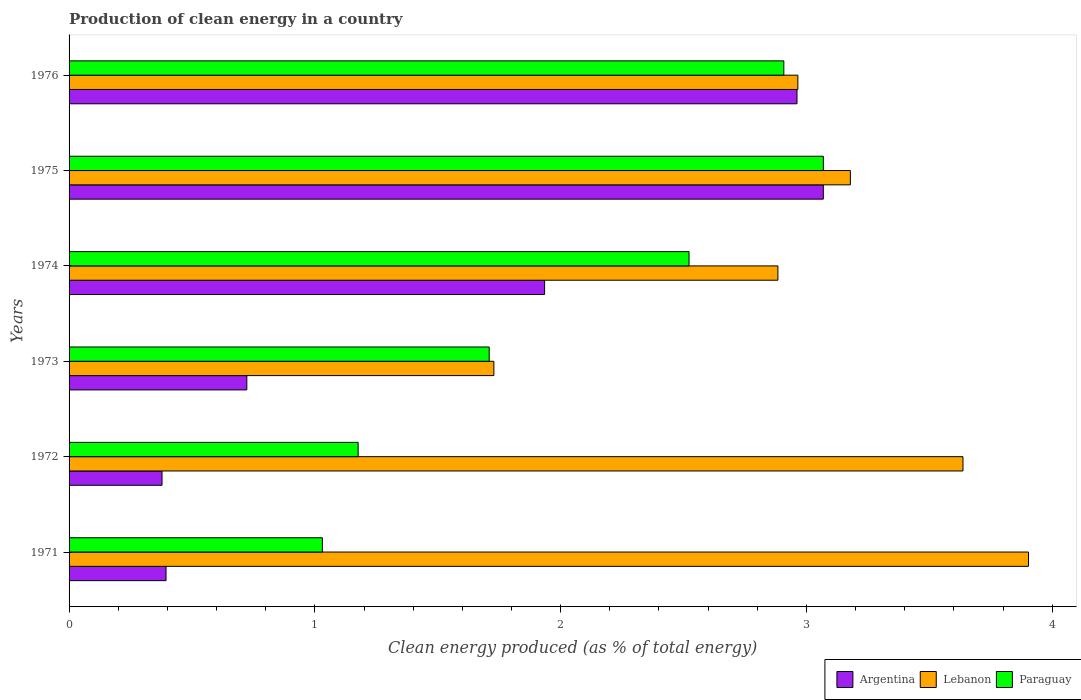How many different coloured bars are there?
Ensure brevity in your answer.  3. How many bars are there on the 6th tick from the top?
Provide a short and direct response. 3. How many bars are there on the 3rd tick from the bottom?
Provide a succinct answer. 3. What is the label of the 3rd group of bars from the top?
Keep it short and to the point. 1974. What is the percentage of clean energy produced in Argentina in 1976?
Ensure brevity in your answer.  2.96. Across all years, what is the maximum percentage of clean energy produced in Lebanon?
Make the answer very short. 3.9. Across all years, what is the minimum percentage of clean energy produced in Paraguay?
Keep it short and to the point. 1.03. In which year was the percentage of clean energy produced in Argentina maximum?
Offer a terse response. 1975. What is the total percentage of clean energy produced in Lebanon in the graph?
Your answer should be very brief. 18.3. What is the difference between the percentage of clean energy produced in Argentina in 1971 and that in 1975?
Make the answer very short. -2.67. What is the difference between the percentage of clean energy produced in Argentina in 1976 and the percentage of clean energy produced in Paraguay in 1972?
Give a very brief answer. 1.79. What is the average percentage of clean energy produced in Lebanon per year?
Your answer should be compact. 3.05. In the year 1974, what is the difference between the percentage of clean energy produced in Argentina and percentage of clean energy produced in Lebanon?
Keep it short and to the point. -0.95. In how many years, is the percentage of clean energy produced in Argentina greater than 2.8 %?
Your answer should be very brief. 2. What is the ratio of the percentage of clean energy produced in Lebanon in 1974 to that in 1975?
Your response must be concise. 0.91. Is the difference between the percentage of clean energy produced in Argentina in 1971 and 1974 greater than the difference between the percentage of clean energy produced in Lebanon in 1971 and 1974?
Offer a very short reply. No. What is the difference between the highest and the second highest percentage of clean energy produced in Paraguay?
Make the answer very short. 0.16. What is the difference between the highest and the lowest percentage of clean energy produced in Argentina?
Your answer should be compact. 2.69. In how many years, is the percentage of clean energy produced in Argentina greater than the average percentage of clean energy produced in Argentina taken over all years?
Your answer should be compact. 3. Is the sum of the percentage of clean energy produced in Argentina in 1972 and 1974 greater than the maximum percentage of clean energy produced in Paraguay across all years?
Make the answer very short. No. What does the 3rd bar from the bottom in 1976 represents?
Give a very brief answer. Paraguay. Are all the bars in the graph horizontal?
Your answer should be compact. Yes. How many years are there in the graph?
Keep it short and to the point. 6. Are the values on the major ticks of X-axis written in scientific E-notation?
Make the answer very short. No. Does the graph contain any zero values?
Offer a terse response. No. Where does the legend appear in the graph?
Offer a very short reply. Bottom right. How many legend labels are there?
Make the answer very short. 3. What is the title of the graph?
Give a very brief answer. Production of clean energy in a country. Does "OECD members" appear as one of the legend labels in the graph?
Ensure brevity in your answer.  No. What is the label or title of the X-axis?
Give a very brief answer. Clean energy produced (as % of total energy). What is the label or title of the Y-axis?
Your answer should be very brief. Years. What is the Clean energy produced (as % of total energy) in Argentina in 1971?
Your response must be concise. 0.39. What is the Clean energy produced (as % of total energy) of Lebanon in 1971?
Provide a succinct answer. 3.9. What is the Clean energy produced (as % of total energy) of Paraguay in 1971?
Your answer should be compact. 1.03. What is the Clean energy produced (as % of total energy) in Argentina in 1972?
Your response must be concise. 0.38. What is the Clean energy produced (as % of total energy) of Lebanon in 1972?
Provide a short and direct response. 3.64. What is the Clean energy produced (as % of total energy) in Paraguay in 1972?
Make the answer very short. 1.18. What is the Clean energy produced (as % of total energy) of Argentina in 1973?
Ensure brevity in your answer.  0.72. What is the Clean energy produced (as % of total energy) in Lebanon in 1973?
Make the answer very short. 1.73. What is the Clean energy produced (as % of total energy) of Paraguay in 1973?
Your answer should be very brief. 1.71. What is the Clean energy produced (as % of total energy) in Argentina in 1974?
Offer a terse response. 1.93. What is the Clean energy produced (as % of total energy) in Lebanon in 1974?
Offer a terse response. 2.88. What is the Clean energy produced (as % of total energy) of Paraguay in 1974?
Your answer should be compact. 2.52. What is the Clean energy produced (as % of total energy) of Argentina in 1975?
Provide a short and direct response. 3.07. What is the Clean energy produced (as % of total energy) of Lebanon in 1975?
Provide a succinct answer. 3.18. What is the Clean energy produced (as % of total energy) of Paraguay in 1975?
Make the answer very short. 3.07. What is the Clean energy produced (as % of total energy) in Argentina in 1976?
Your answer should be compact. 2.96. What is the Clean energy produced (as % of total energy) in Lebanon in 1976?
Your answer should be compact. 2.97. What is the Clean energy produced (as % of total energy) in Paraguay in 1976?
Provide a short and direct response. 2.91. Across all years, what is the maximum Clean energy produced (as % of total energy) in Argentina?
Offer a very short reply. 3.07. Across all years, what is the maximum Clean energy produced (as % of total energy) of Lebanon?
Keep it short and to the point. 3.9. Across all years, what is the maximum Clean energy produced (as % of total energy) of Paraguay?
Give a very brief answer. 3.07. Across all years, what is the minimum Clean energy produced (as % of total energy) in Argentina?
Your answer should be very brief. 0.38. Across all years, what is the minimum Clean energy produced (as % of total energy) in Lebanon?
Your answer should be compact. 1.73. Across all years, what is the minimum Clean energy produced (as % of total energy) of Paraguay?
Provide a succinct answer. 1.03. What is the total Clean energy produced (as % of total energy) in Argentina in the graph?
Ensure brevity in your answer.  9.46. What is the total Clean energy produced (as % of total energy) of Lebanon in the graph?
Your response must be concise. 18.3. What is the total Clean energy produced (as % of total energy) of Paraguay in the graph?
Provide a short and direct response. 12.42. What is the difference between the Clean energy produced (as % of total energy) in Argentina in 1971 and that in 1972?
Provide a succinct answer. 0.02. What is the difference between the Clean energy produced (as % of total energy) in Lebanon in 1971 and that in 1972?
Your answer should be very brief. 0.27. What is the difference between the Clean energy produced (as % of total energy) of Paraguay in 1971 and that in 1972?
Give a very brief answer. -0.15. What is the difference between the Clean energy produced (as % of total energy) of Argentina in 1971 and that in 1973?
Your response must be concise. -0.33. What is the difference between the Clean energy produced (as % of total energy) in Lebanon in 1971 and that in 1973?
Your response must be concise. 2.18. What is the difference between the Clean energy produced (as % of total energy) of Paraguay in 1971 and that in 1973?
Offer a very short reply. -0.68. What is the difference between the Clean energy produced (as % of total energy) in Argentina in 1971 and that in 1974?
Offer a terse response. -1.54. What is the difference between the Clean energy produced (as % of total energy) in Lebanon in 1971 and that in 1974?
Provide a short and direct response. 1.02. What is the difference between the Clean energy produced (as % of total energy) of Paraguay in 1971 and that in 1974?
Give a very brief answer. -1.49. What is the difference between the Clean energy produced (as % of total energy) of Argentina in 1971 and that in 1975?
Make the answer very short. -2.67. What is the difference between the Clean energy produced (as % of total energy) of Lebanon in 1971 and that in 1975?
Give a very brief answer. 0.72. What is the difference between the Clean energy produced (as % of total energy) of Paraguay in 1971 and that in 1975?
Keep it short and to the point. -2.04. What is the difference between the Clean energy produced (as % of total energy) of Argentina in 1971 and that in 1976?
Provide a short and direct response. -2.57. What is the difference between the Clean energy produced (as % of total energy) in Lebanon in 1971 and that in 1976?
Offer a very short reply. 0.94. What is the difference between the Clean energy produced (as % of total energy) in Paraguay in 1971 and that in 1976?
Make the answer very short. -1.88. What is the difference between the Clean energy produced (as % of total energy) of Argentina in 1972 and that in 1973?
Provide a succinct answer. -0.34. What is the difference between the Clean energy produced (as % of total energy) in Lebanon in 1972 and that in 1973?
Your answer should be compact. 1.91. What is the difference between the Clean energy produced (as % of total energy) of Paraguay in 1972 and that in 1973?
Provide a short and direct response. -0.53. What is the difference between the Clean energy produced (as % of total energy) of Argentina in 1972 and that in 1974?
Provide a short and direct response. -1.56. What is the difference between the Clean energy produced (as % of total energy) of Lebanon in 1972 and that in 1974?
Your answer should be compact. 0.75. What is the difference between the Clean energy produced (as % of total energy) in Paraguay in 1972 and that in 1974?
Keep it short and to the point. -1.35. What is the difference between the Clean energy produced (as % of total energy) of Argentina in 1972 and that in 1975?
Make the answer very short. -2.69. What is the difference between the Clean energy produced (as % of total energy) in Lebanon in 1972 and that in 1975?
Provide a succinct answer. 0.46. What is the difference between the Clean energy produced (as % of total energy) in Paraguay in 1972 and that in 1975?
Your answer should be compact. -1.89. What is the difference between the Clean energy produced (as % of total energy) of Argentina in 1972 and that in 1976?
Offer a terse response. -2.58. What is the difference between the Clean energy produced (as % of total energy) of Lebanon in 1972 and that in 1976?
Provide a succinct answer. 0.67. What is the difference between the Clean energy produced (as % of total energy) of Paraguay in 1972 and that in 1976?
Ensure brevity in your answer.  -1.73. What is the difference between the Clean energy produced (as % of total energy) of Argentina in 1973 and that in 1974?
Provide a short and direct response. -1.21. What is the difference between the Clean energy produced (as % of total energy) in Lebanon in 1973 and that in 1974?
Provide a short and direct response. -1.16. What is the difference between the Clean energy produced (as % of total energy) in Paraguay in 1973 and that in 1974?
Make the answer very short. -0.81. What is the difference between the Clean energy produced (as % of total energy) of Argentina in 1973 and that in 1975?
Your answer should be compact. -2.35. What is the difference between the Clean energy produced (as % of total energy) of Lebanon in 1973 and that in 1975?
Your response must be concise. -1.45. What is the difference between the Clean energy produced (as % of total energy) in Paraguay in 1973 and that in 1975?
Give a very brief answer. -1.36. What is the difference between the Clean energy produced (as % of total energy) of Argentina in 1973 and that in 1976?
Keep it short and to the point. -2.24. What is the difference between the Clean energy produced (as % of total energy) in Lebanon in 1973 and that in 1976?
Keep it short and to the point. -1.24. What is the difference between the Clean energy produced (as % of total energy) in Paraguay in 1973 and that in 1976?
Your answer should be compact. -1.2. What is the difference between the Clean energy produced (as % of total energy) of Argentina in 1974 and that in 1975?
Give a very brief answer. -1.13. What is the difference between the Clean energy produced (as % of total energy) in Lebanon in 1974 and that in 1975?
Offer a terse response. -0.29. What is the difference between the Clean energy produced (as % of total energy) in Paraguay in 1974 and that in 1975?
Provide a short and direct response. -0.55. What is the difference between the Clean energy produced (as % of total energy) of Argentina in 1974 and that in 1976?
Ensure brevity in your answer.  -1.03. What is the difference between the Clean energy produced (as % of total energy) of Lebanon in 1974 and that in 1976?
Provide a short and direct response. -0.08. What is the difference between the Clean energy produced (as % of total energy) of Paraguay in 1974 and that in 1976?
Your response must be concise. -0.39. What is the difference between the Clean energy produced (as % of total energy) of Argentina in 1975 and that in 1976?
Provide a short and direct response. 0.11. What is the difference between the Clean energy produced (as % of total energy) in Lebanon in 1975 and that in 1976?
Provide a short and direct response. 0.21. What is the difference between the Clean energy produced (as % of total energy) in Paraguay in 1975 and that in 1976?
Offer a terse response. 0.16. What is the difference between the Clean energy produced (as % of total energy) in Argentina in 1971 and the Clean energy produced (as % of total energy) in Lebanon in 1972?
Your response must be concise. -3.24. What is the difference between the Clean energy produced (as % of total energy) of Argentina in 1971 and the Clean energy produced (as % of total energy) of Paraguay in 1972?
Your answer should be compact. -0.78. What is the difference between the Clean energy produced (as % of total energy) of Lebanon in 1971 and the Clean energy produced (as % of total energy) of Paraguay in 1972?
Give a very brief answer. 2.73. What is the difference between the Clean energy produced (as % of total energy) of Argentina in 1971 and the Clean energy produced (as % of total energy) of Lebanon in 1973?
Offer a very short reply. -1.33. What is the difference between the Clean energy produced (as % of total energy) of Argentina in 1971 and the Clean energy produced (as % of total energy) of Paraguay in 1973?
Make the answer very short. -1.31. What is the difference between the Clean energy produced (as % of total energy) of Lebanon in 1971 and the Clean energy produced (as % of total energy) of Paraguay in 1973?
Your answer should be compact. 2.19. What is the difference between the Clean energy produced (as % of total energy) of Argentina in 1971 and the Clean energy produced (as % of total energy) of Lebanon in 1974?
Provide a short and direct response. -2.49. What is the difference between the Clean energy produced (as % of total energy) in Argentina in 1971 and the Clean energy produced (as % of total energy) in Paraguay in 1974?
Offer a terse response. -2.13. What is the difference between the Clean energy produced (as % of total energy) of Lebanon in 1971 and the Clean energy produced (as % of total energy) of Paraguay in 1974?
Offer a terse response. 1.38. What is the difference between the Clean energy produced (as % of total energy) in Argentina in 1971 and the Clean energy produced (as % of total energy) in Lebanon in 1975?
Provide a short and direct response. -2.78. What is the difference between the Clean energy produced (as % of total energy) of Argentina in 1971 and the Clean energy produced (as % of total energy) of Paraguay in 1975?
Provide a short and direct response. -2.67. What is the difference between the Clean energy produced (as % of total energy) in Lebanon in 1971 and the Clean energy produced (as % of total energy) in Paraguay in 1975?
Make the answer very short. 0.83. What is the difference between the Clean energy produced (as % of total energy) of Argentina in 1971 and the Clean energy produced (as % of total energy) of Lebanon in 1976?
Your answer should be compact. -2.57. What is the difference between the Clean energy produced (as % of total energy) of Argentina in 1971 and the Clean energy produced (as % of total energy) of Paraguay in 1976?
Your response must be concise. -2.51. What is the difference between the Clean energy produced (as % of total energy) of Argentina in 1972 and the Clean energy produced (as % of total energy) of Lebanon in 1973?
Ensure brevity in your answer.  -1.35. What is the difference between the Clean energy produced (as % of total energy) of Argentina in 1972 and the Clean energy produced (as % of total energy) of Paraguay in 1973?
Keep it short and to the point. -1.33. What is the difference between the Clean energy produced (as % of total energy) of Lebanon in 1972 and the Clean energy produced (as % of total energy) of Paraguay in 1973?
Keep it short and to the point. 1.93. What is the difference between the Clean energy produced (as % of total energy) of Argentina in 1972 and the Clean energy produced (as % of total energy) of Lebanon in 1974?
Ensure brevity in your answer.  -2.51. What is the difference between the Clean energy produced (as % of total energy) in Argentina in 1972 and the Clean energy produced (as % of total energy) in Paraguay in 1974?
Provide a succinct answer. -2.14. What is the difference between the Clean energy produced (as % of total energy) of Lebanon in 1972 and the Clean energy produced (as % of total energy) of Paraguay in 1974?
Your response must be concise. 1.11. What is the difference between the Clean energy produced (as % of total energy) in Argentina in 1972 and the Clean energy produced (as % of total energy) in Lebanon in 1975?
Provide a short and direct response. -2.8. What is the difference between the Clean energy produced (as % of total energy) in Argentina in 1972 and the Clean energy produced (as % of total energy) in Paraguay in 1975?
Provide a short and direct response. -2.69. What is the difference between the Clean energy produced (as % of total energy) in Lebanon in 1972 and the Clean energy produced (as % of total energy) in Paraguay in 1975?
Ensure brevity in your answer.  0.57. What is the difference between the Clean energy produced (as % of total energy) in Argentina in 1972 and the Clean energy produced (as % of total energy) in Lebanon in 1976?
Provide a short and direct response. -2.59. What is the difference between the Clean energy produced (as % of total energy) of Argentina in 1972 and the Clean energy produced (as % of total energy) of Paraguay in 1976?
Ensure brevity in your answer.  -2.53. What is the difference between the Clean energy produced (as % of total energy) of Lebanon in 1972 and the Clean energy produced (as % of total energy) of Paraguay in 1976?
Keep it short and to the point. 0.73. What is the difference between the Clean energy produced (as % of total energy) of Argentina in 1973 and the Clean energy produced (as % of total energy) of Lebanon in 1974?
Keep it short and to the point. -2.16. What is the difference between the Clean energy produced (as % of total energy) of Argentina in 1973 and the Clean energy produced (as % of total energy) of Paraguay in 1974?
Your answer should be compact. -1.8. What is the difference between the Clean energy produced (as % of total energy) of Lebanon in 1973 and the Clean energy produced (as % of total energy) of Paraguay in 1974?
Keep it short and to the point. -0.79. What is the difference between the Clean energy produced (as % of total energy) in Argentina in 1973 and the Clean energy produced (as % of total energy) in Lebanon in 1975?
Your response must be concise. -2.46. What is the difference between the Clean energy produced (as % of total energy) in Argentina in 1973 and the Clean energy produced (as % of total energy) in Paraguay in 1975?
Make the answer very short. -2.35. What is the difference between the Clean energy produced (as % of total energy) in Lebanon in 1973 and the Clean energy produced (as % of total energy) in Paraguay in 1975?
Keep it short and to the point. -1.34. What is the difference between the Clean energy produced (as % of total energy) of Argentina in 1973 and the Clean energy produced (as % of total energy) of Lebanon in 1976?
Your answer should be very brief. -2.24. What is the difference between the Clean energy produced (as % of total energy) in Argentina in 1973 and the Clean energy produced (as % of total energy) in Paraguay in 1976?
Ensure brevity in your answer.  -2.19. What is the difference between the Clean energy produced (as % of total energy) in Lebanon in 1973 and the Clean energy produced (as % of total energy) in Paraguay in 1976?
Your answer should be compact. -1.18. What is the difference between the Clean energy produced (as % of total energy) of Argentina in 1974 and the Clean energy produced (as % of total energy) of Lebanon in 1975?
Your answer should be very brief. -1.24. What is the difference between the Clean energy produced (as % of total energy) of Argentina in 1974 and the Clean energy produced (as % of total energy) of Paraguay in 1975?
Provide a succinct answer. -1.13. What is the difference between the Clean energy produced (as % of total energy) in Lebanon in 1974 and the Clean energy produced (as % of total energy) in Paraguay in 1975?
Give a very brief answer. -0.18. What is the difference between the Clean energy produced (as % of total energy) in Argentina in 1974 and the Clean energy produced (as % of total energy) in Lebanon in 1976?
Give a very brief answer. -1.03. What is the difference between the Clean energy produced (as % of total energy) in Argentina in 1974 and the Clean energy produced (as % of total energy) in Paraguay in 1976?
Offer a very short reply. -0.97. What is the difference between the Clean energy produced (as % of total energy) in Lebanon in 1974 and the Clean energy produced (as % of total energy) in Paraguay in 1976?
Provide a succinct answer. -0.02. What is the difference between the Clean energy produced (as % of total energy) in Argentina in 1975 and the Clean energy produced (as % of total energy) in Lebanon in 1976?
Provide a short and direct response. 0.1. What is the difference between the Clean energy produced (as % of total energy) in Argentina in 1975 and the Clean energy produced (as % of total energy) in Paraguay in 1976?
Keep it short and to the point. 0.16. What is the difference between the Clean energy produced (as % of total energy) of Lebanon in 1975 and the Clean energy produced (as % of total energy) of Paraguay in 1976?
Keep it short and to the point. 0.27. What is the average Clean energy produced (as % of total energy) in Argentina per year?
Make the answer very short. 1.58. What is the average Clean energy produced (as % of total energy) in Lebanon per year?
Keep it short and to the point. 3.05. What is the average Clean energy produced (as % of total energy) of Paraguay per year?
Make the answer very short. 2.07. In the year 1971, what is the difference between the Clean energy produced (as % of total energy) of Argentina and Clean energy produced (as % of total energy) of Lebanon?
Offer a very short reply. -3.51. In the year 1971, what is the difference between the Clean energy produced (as % of total energy) in Argentina and Clean energy produced (as % of total energy) in Paraguay?
Offer a very short reply. -0.64. In the year 1971, what is the difference between the Clean energy produced (as % of total energy) in Lebanon and Clean energy produced (as % of total energy) in Paraguay?
Make the answer very short. 2.87. In the year 1972, what is the difference between the Clean energy produced (as % of total energy) in Argentina and Clean energy produced (as % of total energy) in Lebanon?
Offer a very short reply. -3.26. In the year 1972, what is the difference between the Clean energy produced (as % of total energy) in Argentina and Clean energy produced (as % of total energy) in Paraguay?
Ensure brevity in your answer.  -0.8. In the year 1972, what is the difference between the Clean energy produced (as % of total energy) in Lebanon and Clean energy produced (as % of total energy) in Paraguay?
Your response must be concise. 2.46. In the year 1973, what is the difference between the Clean energy produced (as % of total energy) in Argentina and Clean energy produced (as % of total energy) in Lebanon?
Your answer should be compact. -1.01. In the year 1973, what is the difference between the Clean energy produced (as % of total energy) of Argentina and Clean energy produced (as % of total energy) of Paraguay?
Provide a succinct answer. -0.99. In the year 1973, what is the difference between the Clean energy produced (as % of total energy) of Lebanon and Clean energy produced (as % of total energy) of Paraguay?
Your answer should be compact. 0.02. In the year 1974, what is the difference between the Clean energy produced (as % of total energy) of Argentina and Clean energy produced (as % of total energy) of Lebanon?
Offer a very short reply. -0.95. In the year 1974, what is the difference between the Clean energy produced (as % of total energy) in Argentina and Clean energy produced (as % of total energy) in Paraguay?
Your answer should be compact. -0.59. In the year 1974, what is the difference between the Clean energy produced (as % of total energy) of Lebanon and Clean energy produced (as % of total energy) of Paraguay?
Offer a terse response. 0.36. In the year 1975, what is the difference between the Clean energy produced (as % of total energy) of Argentina and Clean energy produced (as % of total energy) of Lebanon?
Your response must be concise. -0.11. In the year 1975, what is the difference between the Clean energy produced (as % of total energy) in Argentina and Clean energy produced (as % of total energy) in Paraguay?
Provide a short and direct response. -0. In the year 1975, what is the difference between the Clean energy produced (as % of total energy) of Lebanon and Clean energy produced (as % of total energy) of Paraguay?
Make the answer very short. 0.11. In the year 1976, what is the difference between the Clean energy produced (as % of total energy) of Argentina and Clean energy produced (as % of total energy) of Lebanon?
Your answer should be very brief. -0. In the year 1976, what is the difference between the Clean energy produced (as % of total energy) in Argentina and Clean energy produced (as % of total energy) in Paraguay?
Ensure brevity in your answer.  0.05. In the year 1976, what is the difference between the Clean energy produced (as % of total energy) in Lebanon and Clean energy produced (as % of total energy) in Paraguay?
Ensure brevity in your answer.  0.06. What is the ratio of the Clean energy produced (as % of total energy) in Argentina in 1971 to that in 1972?
Offer a very short reply. 1.04. What is the ratio of the Clean energy produced (as % of total energy) in Lebanon in 1971 to that in 1972?
Your answer should be compact. 1.07. What is the ratio of the Clean energy produced (as % of total energy) of Paraguay in 1971 to that in 1972?
Your answer should be compact. 0.88. What is the ratio of the Clean energy produced (as % of total energy) of Argentina in 1971 to that in 1973?
Offer a very short reply. 0.55. What is the ratio of the Clean energy produced (as % of total energy) of Lebanon in 1971 to that in 1973?
Provide a succinct answer. 2.26. What is the ratio of the Clean energy produced (as % of total energy) of Paraguay in 1971 to that in 1973?
Offer a very short reply. 0.6. What is the ratio of the Clean energy produced (as % of total energy) of Argentina in 1971 to that in 1974?
Your response must be concise. 0.2. What is the ratio of the Clean energy produced (as % of total energy) of Lebanon in 1971 to that in 1974?
Keep it short and to the point. 1.35. What is the ratio of the Clean energy produced (as % of total energy) in Paraguay in 1971 to that in 1974?
Offer a terse response. 0.41. What is the ratio of the Clean energy produced (as % of total energy) in Argentina in 1971 to that in 1975?
Make the answer very short. 0.13. What is the ratio of the Clean energy produced (as % of total energy) in Lebanon in 1971 to that in 1975?
Offer a very short reply. 1.23. What is the ratio of the Clean energy produced (as % of total energy) of Paraguay in 1971 to that in 1975?
Your answer should be very brief. 0.34. What is the ratio of the Clean energy produced (as % of total energy) in Argentina in 1971 to that in 1976?
Your answer should be very brief. 0.13. What is the ratio of the Clean energy produced (as % of total energy) of Lebanon in 1971 to that in 1976?
Ensure brevity in your answer.  1.32. What is the ratio of the Clean energy produced (as % of total energy) of Paraguay in 1971 to that in 1976?
Your response must be concise. 0.35. What is the ratio of the Clean energy produced (as % of total energy) of Argentina in 1972 to that in 1973?
Offer a very short reply. 0.52. What is the ratio of the Clean energy produced (as % of total energy) of Lebanon in 1972 to that in 1973?
Your answer should be compact. 2.1. What is the ratio of the Clean energy produced (as % of total energy) in Paraguay in 1972 to that in 1973?
Offer a very short reply. 0.69. What is the ratio of the Clean energy produced (as % of total energy) of Argentina in 1972 to that in 1974?
Your answer should be compact. 0.2. What is the ratio of the Clean energy produced (as % of total energy) of Lebanon in 1972 to that in 1974?
Provide a succinct answer. 1.26. What is the ratio of the Clean energy produced (as % of total energy) of Paraguay in 1972 to that in 1974?
Your answer should be compact. 0.47. What is the ratio of the Clean energy produced (as % of total energy) in Argentina in 1972 to that in 1975?
Ensure brevity in your answer.  0.12. What is the ratio of the Clean energy produced (as % of total energy) of Lebanon in 1972 to that in 1975?
Make the answer very short. 1.14. What is the ratio of the Clean energy produced (as % of total energy) in Paraguay in 1972 to that in 1975?
Offer a terse response. 0.38. What is the ratio of the Clean energy produced (as % of total energy) in Argentina in 1972 to that in 1976?
Provide a succinct answer. 0.13. What is the ratio of the Clean energy produced (as % of total energy) in Lebanon in 1972 to that in 1976?
Provide a short and direct response. 1.23. What is the ratio of the Clean energy produced (as % of total energy) in Paraguay in 1972 to that in 1976?
Keep it short and to the point. 0.4. What is the ratio of the Clean energy produced (as % of total energy) of Argentina in 1973 to that in 1974?
Keep it short and to the point. 0.37. What is the ratio of the Clean energy produced (as % of total energy) of Lebanon in 1973 to that in 1974?
Make the answer very short. 0.6. What is the ratio of the Clean energy produced (as % of total energy) of Paraguay in 1973 to that in 1974?
Ensure brevity in your answer.  0.68. What is the ratio of the Clean energy produced (as % of total energy) of Argentina in 1973 to that in 1975?
Offer a terse response. 0.24. What is the ratio of the Clean energy produced (as % of total energy) of Lebanon in 1973 to that in 1975?
Provide a succinct answer. 0.54. What is the ratio of the Clean energy produced (as % of total energy) in Paraguay in 1973 to that in 1975?
Keep it short and to the point. 0.56. What is the ratio of the Clean energy produced (as % of total energy) of Argentina in 1973 to that in 1976?
Make the answer very short. 0.24. What is the ratio of the Clean energy produced (as % of total energy) in Lebanon in 1973 to that in 1976?
Offer a terse response. 0.58. What is the ratio of the Clean energy produced (as % of total energy) in Paraguay in 1973 to that in 1976?
Your answer should be very brief. 0.59. What is the ratio of the Clean energy produced (as % of total energy) of Argentina in 1974 to that in 1975?
Provide a short and direct response. 0.63. What is the ratio of the Clean energy produced (as % of total energy) in Lebanon in 1974 to that in 1975?
Offer a very short reply. 0.91. What is the ratio of the Clean energy produced (as % of total energy) of Paraguay in 1974 to that in 1975?
Provide a succinct answer. 0.82. What is the ratio of the Clean energy produced (as % of total energy) in Argentina in 1974 to that in 1976?
Your answer should be compact. 0.65. What is the ratio of the Clean energy produced (as % of total energy) in Lebanon in 1974 to that in 1976?
Ensure brevity in your answer.  0.97. What is the ratio of the Clean energy produced (as % of total energy) of Paraguay in 1974 to that in 1976?
Ensure brevity in your answer.  0.87. What is the ratio of the Clean energy produced (as % of total energy) in Argentina in 1975 to that in 1976?
Provide a succinct answer. 1.04. What is the ratio of the Clean energy produced (as % of total energy) of Lebanon in 1975 to that in 1976?
Make the answer very short. 1.07. What is the ratio of the Clean energy produced (as % of total energy) in Paraguay in 1975 to that in 1976?
Keep it short and to the point. 1.06. What is the difference between the highest and the second highest Clean energy produced (as % of total energy) of Argentina?
Give a very brief answer. 0.11. What is the difference between the highest and the second highest Clean energy produced (as % of total energy) of Lebanon?
Offer a terse response. 0.27. What is the difference between the highest and the second highest Clean energy produced (as % of total energy) in Paraguay?
Offer a very short reply. 0.16. What is the difference between the highest and the lowest Clean energy produced (as % of total energy) of Argentina?
Your response must be concise. 2.69. What is the difference between the highest and the lowest Clean energy produced (as % of total energy) in Lebanon?
Your answer should be very brief. 2.18. What is the difference between the highest and the lowest Clean energy produced (as % of total energy) in Paraguay?
Make the answer very short. 2.04. 